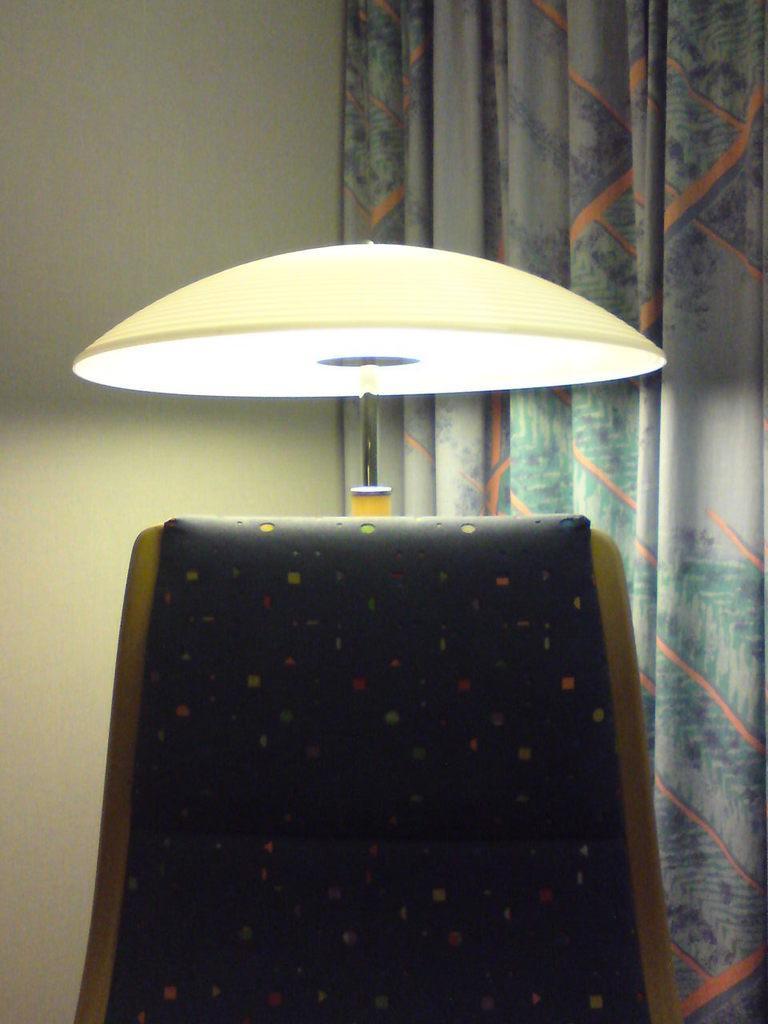In one or two sentences, can you explain what this image depicts? In this picture I can see in the middle there is a lamp, on the right side there is a curtain, and on the left side there is a wall. 